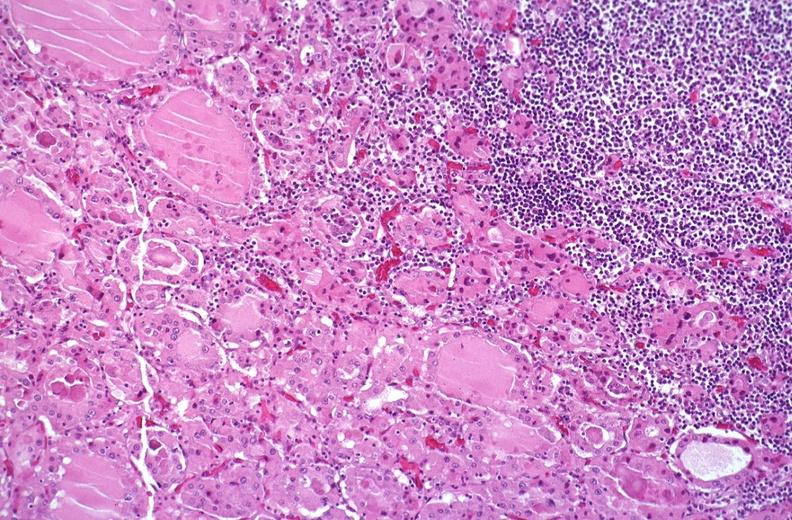does this image show hashimoto 's thyroiditis?
Answer the question using a single word or phrase. Yes 